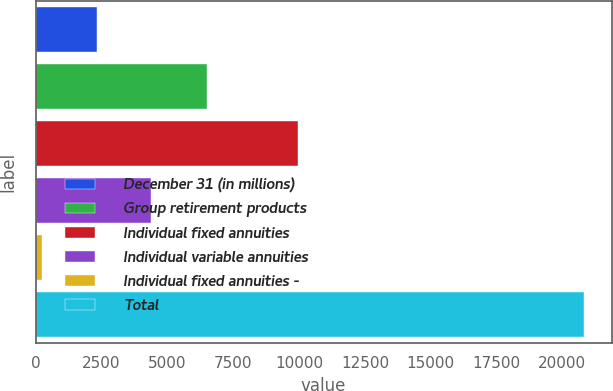Convert chart to OTSL. <chart><loc_0><loc_0><loc_500><loc_500><bar_chart><fcel>December 31 (in millions)<fcel>Group retirement products<fcel>Individual fixed annuities<fcel>Individual variable annuities<fcel>Individual fixed annuities -<fcel>Total<nl><fcel>2310.5<fcel>6502<fcel>9947<fcel>4368<fcel>253<fcel>20828<nl></chart> 